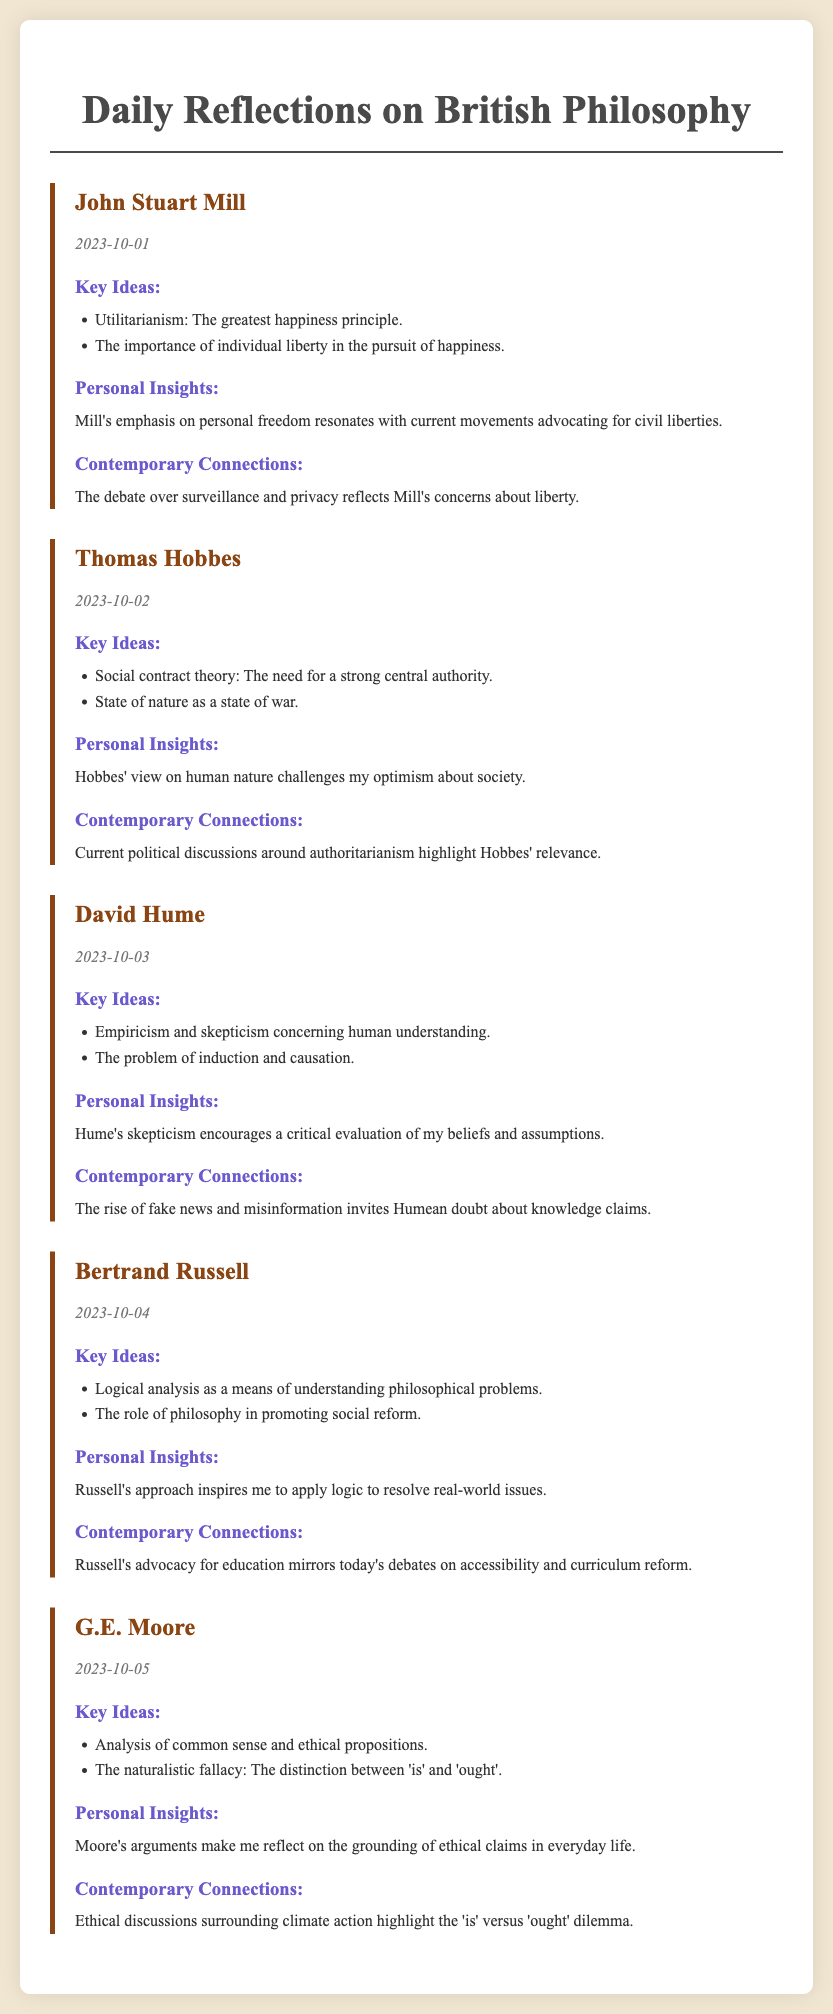What is the title of the document? The title of the document is provided in the heading of the HTML structure.
Answer: Daily Reflections on British Philosophy Who is the philosopher discussed on October 2, 2023? The date corresponds to a specific reflection in the document which includes the name of the philosopher.
Answer: Thomas Hobbes What is the key idea associated with David Hume? The key ideas for each philosopher are listed under the respective section in the document.
Answer: Empiricism and skepticism concerning human understanding What is one contemporary connection related to John Stuart Mill? The contemporary connections are listed in the reflection for each philosopher.
Answer: The debate over surveillance and privacy reflects Mill's concerns about liberty What is G.E. Moore known for discussing? The document provides the key ideas associated with each philosopher upon their reflection.
Answer: The naturalistic fallacy: The distinction between 'is' and 'ought' How many philosophers are featured in the document? The document lists a number of reflections, each corresponding to a different philosopher.
Answer: Five What personal insight does the author have about Bertrand Russell? Personal insights are shared in the reflection for each philosopher, summarizing the author's views.
Answer: Russell's approach inspires me to apply logic to resolve real-world issues What date is associated with David Hume? Each philosopher's reflection includes the date of the entry.
Answer: 2023-10-03 Which philosopher emphasized individual liberty? The document highlights key ideas and themes associated with each philosopher's reflection.
Answer: John Stuart Mill 